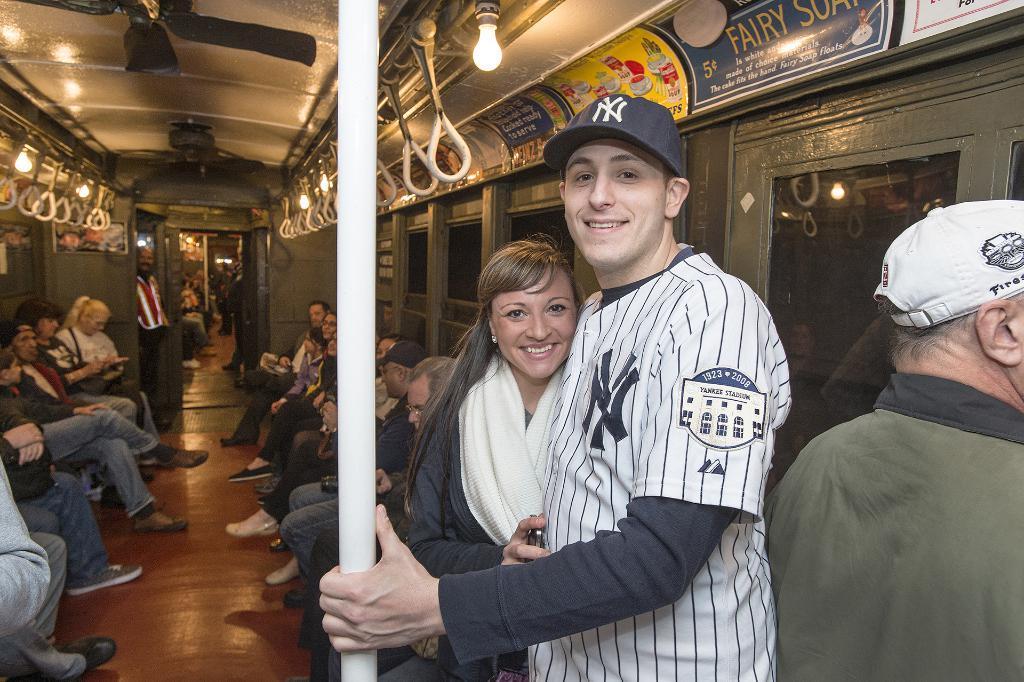Please provide a concise description of this image. This image consists of a train. In which there are many persons. In the front, there is a man holding a rod. Beside him, there is a woman wearing a white scarf. At the top, we can see the fans along with lamps. At the bottom, there is a floor. On the right, there is a door. 